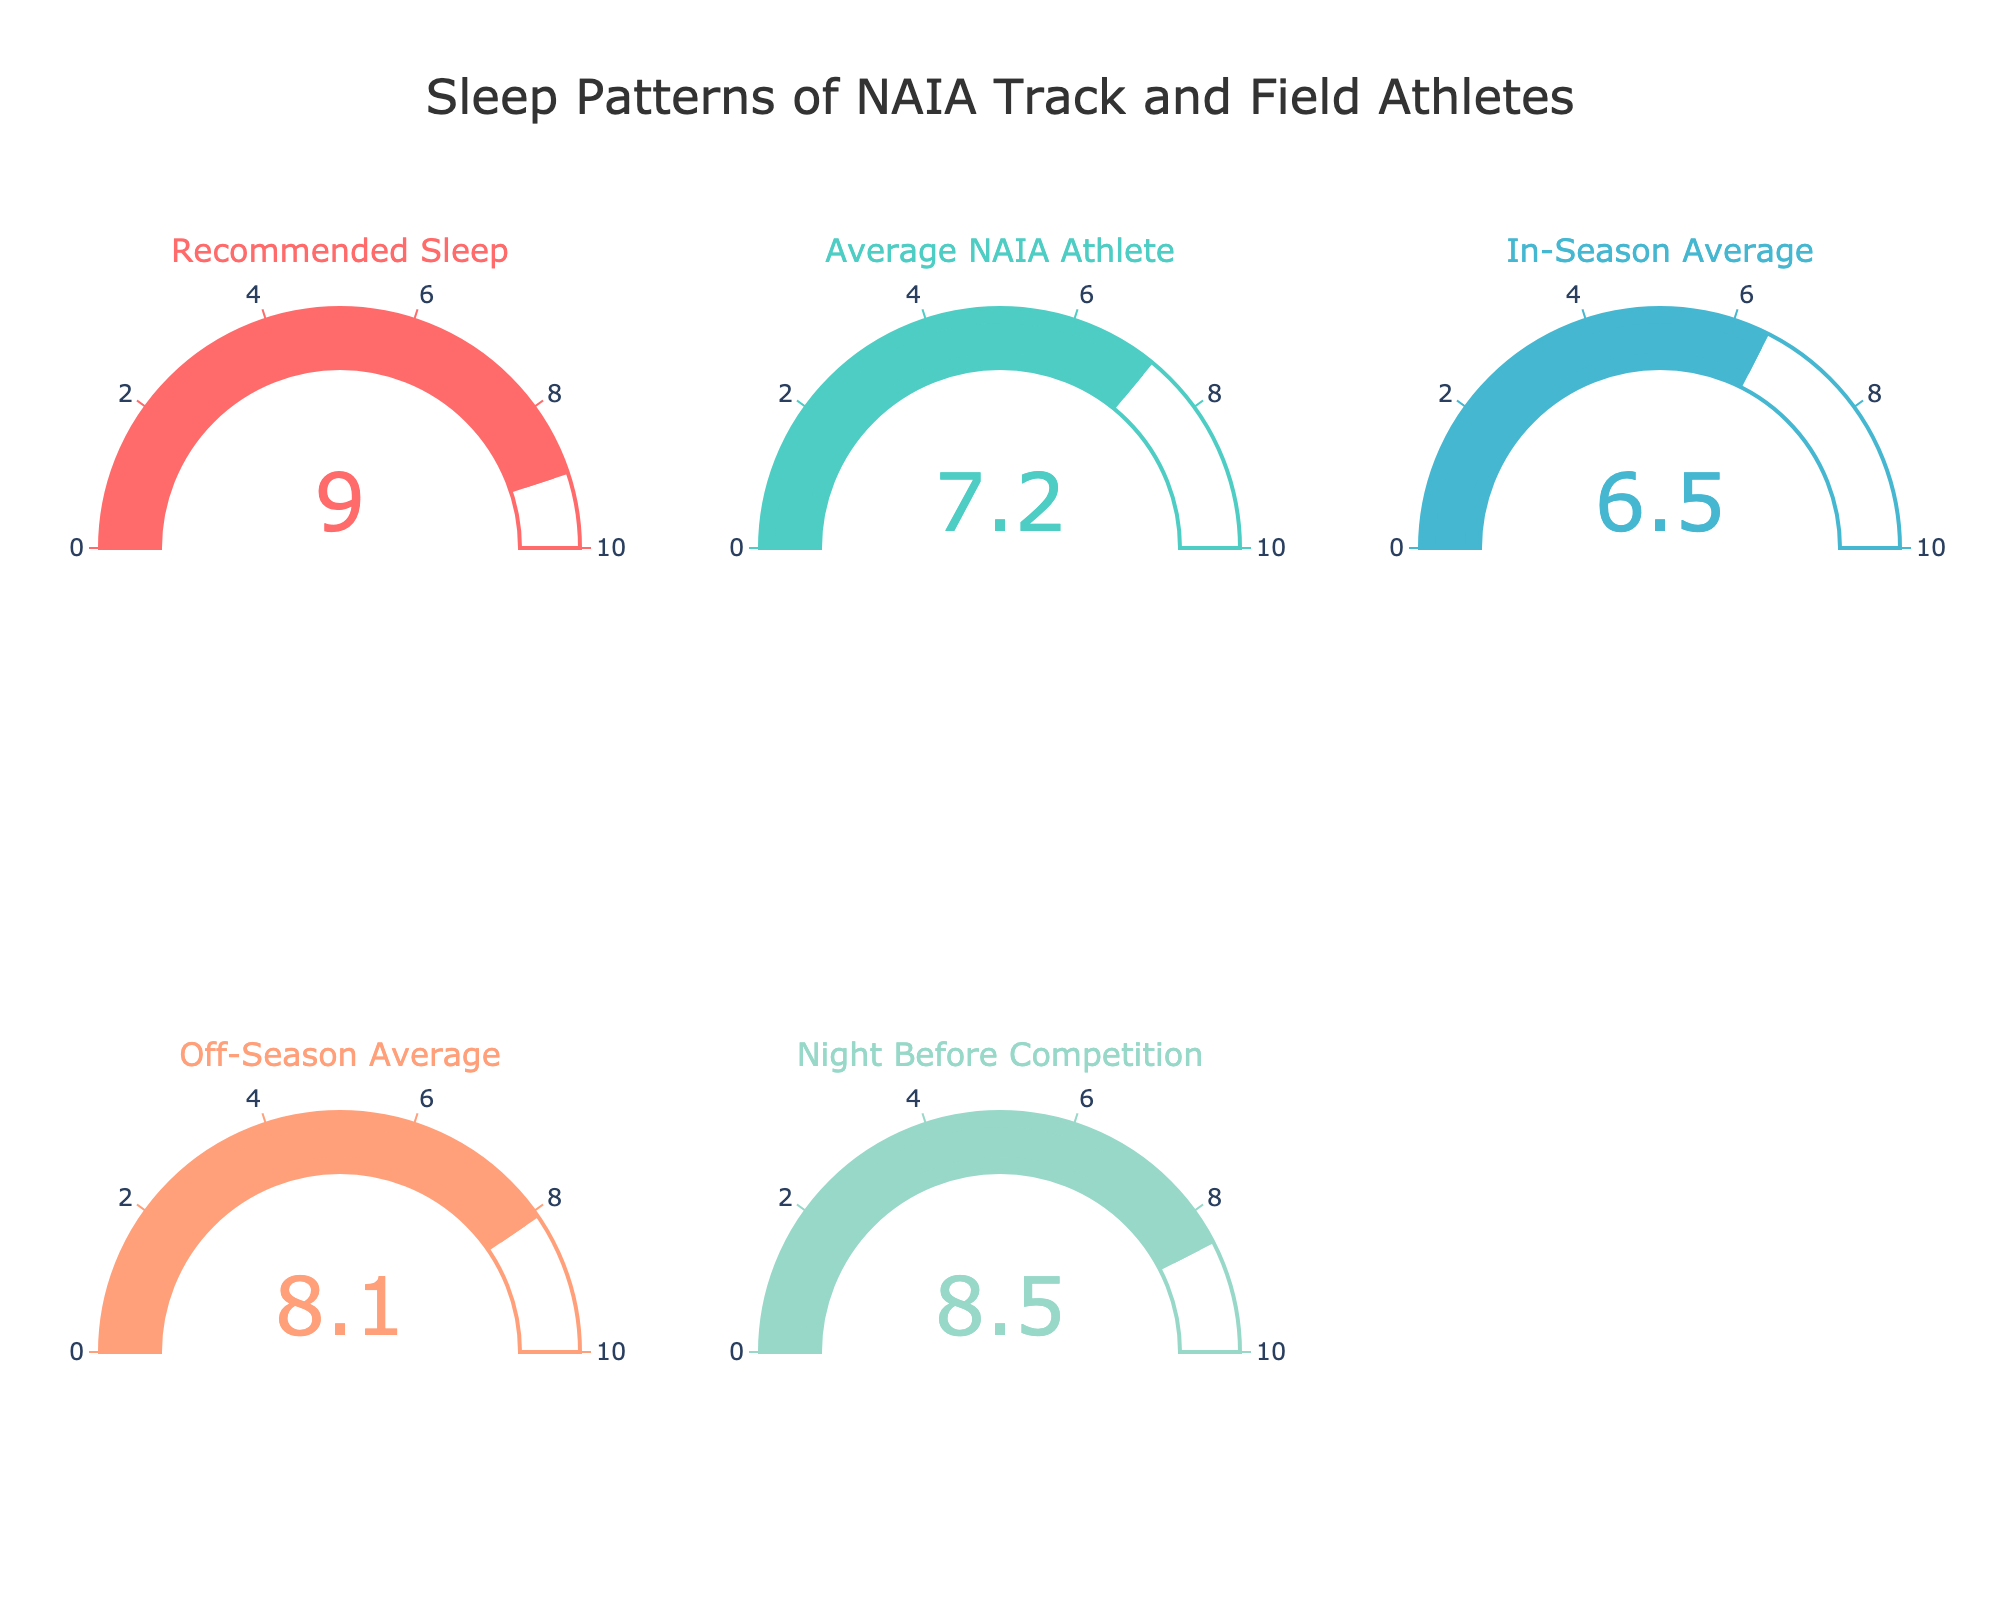what is the title of the figure? The title of the figure is often located at the top of the visual, providing a summary of the dataset being visualized. In this case, the title is "Sleep Patterns of NAIA Track and Field Athletes".
Answer: Sleep Patterns of NAIA Track and Field Athletes what is the recommended average hours of sleep per night? To find the recommended average hours of sleep, locate the gauge titled "Recommended Sleep" and check the value displayed on it. The value indicated is 9 hours.
Answer: 9 hours how many categories are displayed in the figure? Each gauge represents a different category. Counting all the separate gauges will tell us how many categories are present. There are five gauges, so there are five categories in the figure.
Answer: 5 categories how much more sleep does the average NAIA athlete get in the off-season compared to the in-season? To find the difference, look at the values on the gauges for "Off-Season Average" and "In-Season Average". The off-season average is 8.1 hours, and the in-season average is 6.5 hours. Subtracting these values gives a difference of 1.6 hours.
Answer: 1.6 hours which category has the lowest amount of sleep? Identify the gauge with the smallest number. The "In-Season Average" gauge shows the lowest value, 6.5 hours.
Answer: In-Season Average does the average NAIA athlete get more sleep on the night before a competition compared to the in-season average? Compare the values of "Night Before Competition" and "In-Season Average". The "Night Before Competition" value is 8.5 hours, and the "In-Season Average" value is 6.5 hours. Since 8.5 is greater than 6.5, the answer is yes.
Answer: Yes what is the average amount of sleep for an NAIA athlete across all categories? Add all the values together and divide by the number of categories. The values are 7.2 (Average NAIA Athlete), 6.5 (In-Season Average), 8.1 (Off-Season Average), 8.5 (Night Before Competition), and 9 (Recommended Sleep). The sum is 39.3, and dividing by 5 categories gives an average of 7.86 hours.
Answer: 7.86 hours by how many hours does the sleep of an average NAIA athlete fall short of the recommended sleep? Subtract the "Average NAIA Athlete" value from the "Recommended Sleep" value: 9 hours - 7.2 hours = 1.8 hours.
Answer: 1.8 hours which color represents the recommended sleep? Each gauge is colored uniquely. Identify the color associated with the "Recommended Sleep" gauge, which is red (denoted by #FF6B6B in the hex color code).
Answer: Red 